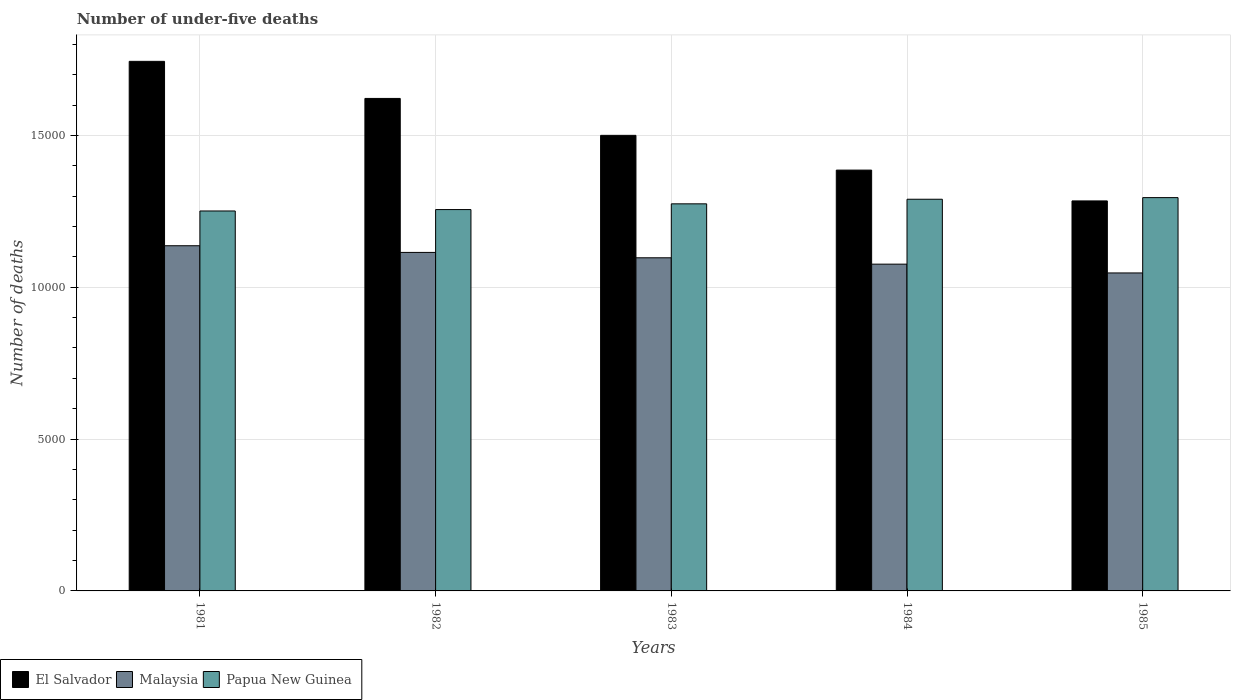How many different coloured bars are there?
Your answer should be very brief. 3. How many groups of bars are there?
Your response must be concise. 5. How many bars are there on the 1st tick from the right?
Your response must be concise. 3. What is the label of the 1st group of bars from the left?
Your response must be concise. 1981. In how many cases, is the number of bars for a given year not equal to the number of legend labels?
Your answer should be very brief. 0. What is the number of under-five deaths in El Salvador in 1983?
Give a very brief answer. 1.50e+04. Across all years, what is the maximum number of under-five deaths in Malaysia?
Make the answer very short. 1.14e+04. Across all years, what is the minimum number of under-five deaths in Papua New Guinea?
Your answer should be very brief. 1.25e+04. In which year was the number of under-five deaths in Papua New Guinea maximum?
Provide a short and direct response. 1985. What is the total number of under-five deaths in El Salvador in the graph?
Offer a terse response. 7.54e+04. What is the difference between the number of under-five deaths in Malaysia in 1983 and that in 1984?
Your answer should be very brief. 209. What is the difference between the number of under-five deaths in El Salvador in 1983 and the number of under-five deaths in Malaysia in 1985?
Your response must be concise. 4531. What is the average number of under-five deaths in Papua New Guinea per year?
Offer a very short reply. 1.27e+04. In the year 1983, what is the difference between the number of under-five deaths in Papua New Guinea and number of under-five deaths in Malaysia?
Make the answer very short. 1777. In how many years, is the number of under-five deaths in Papua New Guinea greater than 5000?
Keep it short and to the point. 5. What is the ratio of the number of under-five deaths in Papua New Guinea in 1982 to that in 1985?
Ensure brevity in your answer.  0.97. Is the difference between the number of under-five deaths in Papua New Guinea in 1982 and 1984 greater than the difference between the number of under-five deaths in Malaysia in 1982 and 1984?
Your answer should be compact. No. What is the difference between the highest and the second highest number of under-five deaths in Papua New Guinea?
Provide a succinct answer. 54. What is the difference between the highest and the lowest number of under-five deaths in El Salvador?
Offer a very short reply. 4596. Is the sum of the number of under-five deaths in Malaysia in 1981 and 1984 greater than the maximum number of under-five deaths in El Salvador across all years?
Offer a very short reply. Yes. What does the 1st bar from the left in 1984 represents?
Your answer should be very brief. El Salvador. What does the 1st bar from the right in 1981 represents?
Your answer should be very brief. Papua New Guinea. Is it the case that in every year, the sum of the number of under-five deaths in Malaysia and number of under-five deaths in Papua New Guinea is greater than the number of under-five deaths in El Salvador?
Ensure brevity in your answer.  Yes. Are all the bars in the graph horizontal?
Keep it short and to the point. No. Does the graph contain grids?
Ensure brevity in your answer.  Yes. What is the title of the graph?
Ensure brevity in your answer.  Number of under-five deaths. What is the label or title of the Y-axis?
Your answer should be very brief. Number of deaths. What is the Number of deaths in El Salvador in 1981?
Provide a short and direct response. 1.74e+04. What is the Number of deaths of Malaysia in 1981?
Make the answer very short. 1.14e+04. What is the Number of deaths of Papua New Guinea in 1981?
Keep it short and to the point. 1.25e+04. What is the Number of deaths of El Salvador in 1982?
Offer a very short reply. 1.62e+04. What is the Number of deaths in Malaysia in 1982?
Provide a succinct answer. 1.11e+04. What is the Number of deaths of Papua New Guinea in 1982?
Provide a short and direct response. 1.26e+04. What is the Number of deaths in El Salvador in 1983?
Give a very brief answer. 1.50e+04. What is the Number of deaths in Malaysia in 1983?
Offer a very short reply. 1.10e+04. What is the Number of deaths in Papua New Guinea in 1983?
Make the answer very short. 1.27e+04. What is the Number of deaths of El Salvador in 1984?
Offer a terse response. 1.39e+04. What is the Number of deaths of Malaysia in 1984?
Offer a very short reply. 1.08e+04. What is the Number of deaths in Papua New Guinea in 1984?
Make the answer very short. 1.29e+04. What is the Number of deaths in El Salvador in 1985?
Give a very brief answer. 1.28e+04. What is the Number of deaths in Malaysia in 1985?
Ensure brevity in your answer.  1.05e+04. What is the Number of deaths in Papua New Guinea in 1985?
Provide a short and direct response. 1.30e+04. Across all years, what is the maximum Number of deaths in El Salvador?
Give a very brief answer. 1.74e+04. Across all years, what is the maximum Number of deaths of Malaysia?
Your response must be concise. 1.14e+04. Across all years, what is the maximum Number of deaths in Papua New Guinea?
Your response must be concise. 1.30e+04. Across all years, what is the minimum Number of deaths of El Salvador?
Offer a terse response. 1.28e+04. Across all years, what is the minimum Number of deaths of Malaysia?
Give a very brief answer. 1.05e+04. Across all years, what is the minimum Number of deaths of Papua New Guinea?
Make the answer very short. 1.25e+04. What is the total Number of deaths of El Salvador in the graph?
Provide a short and direct response. 7.54e+04. What is the total Number of deaths of Malaysia in the graph?
Offer a terse response. 5.47e+04. What is the total Number of deaths in Papua New Guinea in the graph?
Ensure brevity in your answer.  6.37e+04. What is the difference between the Number of deaths in El Salvador in 1981 and that in 1982?
Give a very brief answer. 1221. What is the difference between the Number of deaths in Malaysia in 1981 and that in 1982?
Keep it short and to the point. 220. What is the difference between the Number of deaths of Papua New Guinea in 1981 and that in 1982?
Provide a succinct answer. -46. What is the difference between the Number of deaths in El Salvador in 1981 and that in 1983?
Your answer should be very brief. 2437. What is the difference between the Number of deaths of Malaysia in 1981 and that in 1983?
Offer a terse response. 397. What is the difference between the Number of deaths in Papua New Guinea in 1981 and that in 1983?
Give a very brief answer. -235. What is the difference between the Number of deaths of El Salvador in 1981 and that in 1984?
Make the answer very short. 3581. What is the difference between the Number of deaths in Malaysia in 1981 and that in 1984?
Ensure brevity in your answer.  606. What is the difference between the Number of deaths in Papua New Guinea in 1981 and that in 1984?
Offer a terse response. -386. What is the difference between the Number of deaths of El Salvador in 1981 and that in 1985?
Give a very brief answer. 4596. What is the difference between the Number of deaths of Malaysia in 1981 and that in 1985?
Your answer should be compact. 896. What is the difference between the Number of deaths of Papua New Guinea in 1981 and that in 1985?
Offer a terse response. -440. What is the difference between the Number of deaths of El Salvador in 1982 and that in 1983?
Make the answer very short. 1216. What is the difference between the Number of deaths of Malaysia in 1982 and that in 1983?
Offer a terse response. 177. What is the difference between the Number of deaths of Papua New Guinea in 1982 and that in 1983?
Keep it short and to the point. -189. What is the difference between the Number of deaths of El Salvador in 1982 and that in 1984?
Offer a terse response. 2360. What is the difference between the Number of deaths in Malaysia in 1982 and that in 1984?
Ensure brevity in your answer.  386. What is the difference between the Number of deaths of Papua New Guinea in 1982 and that in 1984?
Offer a very short reply. -340. What is the difference between the Number of deaths in El Salvador in 1982 and that in 1985?
Your answer should be very brief. 3375. What is the difference between the Number of deaths of Malaysia in 1982 and that in 1985?
Provide a succinct answer. 676. What is the difference between the Number of deaths in Papua New Guinea in 1982 and that in 1985?
Give a very brief answer. -394. What is the difference between the Number of deaths of El Salvador in 1983 and that in 1984?
Provide a succinct answer. 1144. What is the difference between the Number of deaths of Malaysia in 1983 and that in 1984?
Keep it short and to the point. 209. What is the difference between the Number of deaths in Papua New Guinea in 1983 and that in 1984?
Offer a terse response. -151. What is the difference between the Number of deaths of El Salvador in 1983 and that in 1985?
Offer a terse response. 2159. What is the difference between the Number of deaths in Malaysia in 1983 and that in 1985?
Provide a short and direct response. 499. What is the difference between the Number of deaths of Papua New Guinea in 1983 and that in 1985?
Your response must be concise. -205. What is the difference between the Number of deaths of El Salvador in 1984 and that in 1985?
Provide a succinct answer. 1015. What is the difference between the Number of deaths of Malaysia in 1984 and that in 1985?
Your response must be concise. 290. What is the difference between the Number of deaths in Papua New Guinea in 1984 and that in 1985?
Ensure brevity in your answer.  -54. What is the difference between the Number of deaths of El Salvador in 1981 and the Number of deaths of Malaysia in 1982?
Offer a terse response. 6292. What is the difference between the Number of deaths in El Salvador in 1981 and the Number of deaths in Papua New Guinea in 1982?
Give a very brief answer. 4881. What is the difference between the Number of deaths of Malaysia in 1981 and the Number of deaths of Papua New Guinea in 1982?
Make the answer very short. -1191. What is the difference between the Number of deaths in El Salvador in 1981 and the Number of deaths in Malaysia in 1983?
Make the answer very short. 6469. What is the difference between the Number of deaths in El Salvador in 1981 and the Number of deaths in Papua New Guinea in 1983?
Offer a very short reply. 4692. What is the difference between the Number of deaths in Malaysia in 1981 and the Number of deaths in Papua New Guinea in 1983?
Your answer should be very brief. -1380. What is the difference between the Number of deaths in El Salvador in 1981 and the Number of deaths in Malaysia in 1984?
Give a very brief answer. 6678. What is the difference between the Number of deaths in El Salvador in 1981 and the Number of deaths in Papua New Guinea in 1984?
Ensure brevity in your answer.  4541. What is the difference between the Number of deaths of Malaysia in 1981 and the Number of deaths of Papua New Guinea in 1984?
Your answer should be compact. -1531. What is the difference between the Number of deaths in El Salvador in 1981 and the Number of deaths in Malaysia in 1985?
Your answer should be compact. 6968. What is the difference between the Number of deaths in El Salvador in 1981 and the Number of deaths in Papua New Guinea in 1985?
Your response must be concise. 4487. What is the difference between the Number of deaths of Malaysia in 1981 and the Number of deaths of Papua New Guinea in 1985?
Your answer should be compact. -1585. What is the difference between the Number of deaths of El Salvador in 1982 and the Number of deaths of Malaysia in 1983?
Give a very brief answer. 5248. What is the difference between the Number of deaths in El Salvador in 1982 and the Number of deaths in Papua New Guinea in 1983?
Offer a very short reply. 3471. What is the difference between the Number of deaths in Malaysia in 1982 and the Number of deaths in Papua New Guinea in 1983?
Make the answer very short. -1600. What is the difference between the Number of deaths in El Salvador in 1982 and the Number of deaths in Malaysia in 1984?
Provide a succinct answer. 5457. What is the difference between the Number of deaths of El Salvador in 1982 and the Number of deaths of Papua New Guinea in 1984?
Ensure brevity in your answer.  3320. What is the difference between the Number of deaths in Malaysia in 1982 and the Number of deaths in Papua New Guinea in 1984?
Your response must be concise. -1751. What is the difference between the Number of deaths in El Salvador in 1982 and the Number of deaths in Malaysia in 1985?
Make the answer very short. 5747. What is the difference between the Number of deaths of El Salvador in 1982 and the Number of deaths of Papua New Guinea in 1985?
Offer a very short reply. 3266. What is the difference between the Number of deaths of Malaysia in 1982 and the Number of deaths of Papua New Guinea in 1985?
Provide a succinct answer. -1805. What is the difference between the Number of deaths of El Salvador in 1983 and the Number of deaths of Malaysia in 1984?
Make the answer very short. 4241. What is the difference between the Number of deaths in El Salvador in 1983 and the Number of deaths in Papua New Guinea in 1984?
Keep it short and to the point. 2104. What is the difference between the Number of deaths in Malaysia in 1983 and the Number of deaths in Papua New Guinea in 1984?
Offer a very short reply. -1928. What is the difference between the Number of deaths of El Salvador in 1983 and the Number of deaths of Malaysia in 1985?
Your answer should be very brief. 4531. What is the difference between the Number of deaths of El Salvador in 1983 and the Number of deaths of Papua New Guinea in 1985?
Make the answer very short. 2050. What is the difference between the Number of deaths of Malaysia in 1983 and the Number of deaths of Papua New Guinea in 1985?
Ensure brevity in your answer.  -1982. What is the difference between the Number of deaths in El Salvador in 1984 and the Number of deaths in Malaysia in 1985?
Your answer should be compact. 3387. What is the difference between the Number of deaths in El Salvador in 1984 and the Number of deaths in Papua New Guinea in 1985?
Your answer should be very brief. 906. What is the difference between the Number of deaths in Malaysia in 1984 and the Number of deaths in Papua New Guinea in 1985?
Provide a short and direct response. -2191. What is the average Number of deaths in El Salvador per year?
Make the answer very short. 1.51e+04. What is the average Number of deaths of Malaysia per year?
Offer a very short reply. 1.09e+04. What is the average Number of deaths in Papua New Guinea per year?
Offer a very short reply. 1.27e+04. In the year 1981, what is the difference between the Number of deaths in El Salvador and Number of deaths in Malaysia?
Your answer should be compact. 6072. In the year 1981, what is the difference between the Number of deaths in El Salvador and Number of deaths in Papua New Guinea?
Your answer should be compact. 4927. In the year 1981, what is the difference between the Number of deaths in Malaysia and Number of deaths in Papua New Guinea?
Ensure brevity in your answer.  -1145. In the year 1982, what is the difference between the Number of deaths of El Salvador and Number of deaths of Malaysia?
Make the answer very short. 5071. In the year 1982, what is the difference between the Number of deaths in El Salvador and Number of deaths in Papua New Guinea?
Keep it short and to the point. 3660. In the year 1982, what is the difference between the Number of deaths of Malaysia and Number of deaths of Papua New Guinea?
Your answer should be compact. -1411. In the year 1983, what is the difference between the Number of deaths in El Salvador and Number of deaths in Malaysia?
Provide a short and direct response. 4032. In the year 1983, what is the difference between the Number of deaths in El Salvador and Number of deaths in Papua New Guinea?
Make the answer very short. 2255. In the year 1983, what is the difference between the Number of deaths of Malaysia and Number of deaths of Papua New Guinea?
Give a very brief answer. -1777. In the year 1984, what is the difference between the Number of deaths in El Salvador and Number of deaths in Malaysia?
Make the answer very short. 3097. In the year 1984, what is the difference between the Number of deaths of El Salvador and Number of deaths of Papua New Guinea?
Provide a succinct answer. 960. In the year 1984, what is the difference between the Number of deaths of Malaysia and Number of deaths of Papua New Guinea?
Keep it short and to the point. -2137. In the year 1985, what is the difference between the Number of deaths in El Salvador and Number of deaths in Malaysia?
Offer a very short reply. 2372. In the year 1985, what is the difference between the Number of deaths in El Salvador and Number of deaths in Papua New Guinea?
Give a very brief answer. -109. In the year 1985, what is the difference between the Number of deaths of Malaysia and Number of deaths of Papua New Guinea?
Ensure brevity in your answer.  -2481. What is the ratio of the Number of deaths of El Salvador in 1981 to that in 1982?
Keep it short and to the point. 1.08. What is the ratio of the Number of deaths of Malaysia in 1981 to that in 1982?
Keep it short and to the point. 1.02. What is the ratio of the Number of deaths in El Salvador in 1981 to that in 1983?
Give a very brief answer. 1.16. What is the ratio of the Number of deaths of Malaysia in 1981 to that in 1983?
Give a very brief answer. 1.04. What is the ratio of the Number of deaths of Papua New Guinea in 1981 to that in 1983?
Offer a terse response. 0.98. What is the ratio of the Number of deaths in El Salvador in 1981 to that in 1984?
Offer a terse response. 1.26. What is the ratio of the Number of deaths in Malaysia in 1981 to that in 1984?
Your answer should be very brief. 1.06. What is the ratio of the Number of deaths in Papua New Guinea in 1981 to that in 1984?
Your answer should be very brief. 0.97. What is the ratio of the Number of deaths in El Salvador in 1981 to that in 1985?
Your response must be concise. 1.36. What is the ratio of the Number of deaths in Malaysia in 1981 to that in 1985?
Your answer should be very brief. 1.09. What is the ratio of the Number of deaths in El Salvador in 1982 to that in 1983?
Offer a very short reply. 1.08. What is the ratio of the Number of deaths in Malaysia in 1982 to that in 1983?
Provide a succinct answer. 1.02. What is the ratio of the Number of deaths of Papua New Guinea in 1982 to that in 1983?
Your answer should be compact. 0.99. What is the ratio of the Number of deaths of El Salvador in 1982 to that in 1984?
Keep it short and to the point. 1.17. What is the ratio of the Number of deaths of Malaysia in 1982 to that in 1984?
Make the answer very short. 1.04. What is the ratio of the Number of deaths of Papua New Guinea in 1982 to that in 1984?
Provide a short and direct response. 0.97. What is the ratio of the Number of deaths in El Salvador in 1982 to that in 1985?
Offer a terse response. 1.26. What is the ratio of the Number of deaths in Malaysia in 1982 to that in 1985?
Offer a very short reply. 1.06. What is the ratio of the Number of deaths of Papua New Guinea in 1982 to that in 1985?
Provide a succinct answer. 0.97. What is the ratio of the Number of deaths of El Salvador in 1983 to that in 1984?
Ensure brevity in your answer.  1.08. What is the ratio of the Number of deaths in Malaysia in 1983 to that in 1984?
Ensure brevity in your answer.  1.02. What is the ratio of the Number of deaths of Papua New Guinea in 1983 to that in 1984?
Provide a succinct answer. 0.99. What is the ratio of the Number of deaths of El Salvador in 1983 to that in 1985?
Offer a very short reply. 1.17. What is the ratio of the Number of deaths in Malaysia in 1983 to that in 1985?
Make the answer very short. 1.05. What is the ratio of the Number of deaths of Papua New Guinea in 1983 to that in 1985?
Give a very brief answer. 0.98. What is the ratio of the Number of deaths of El Salvador in 1984 to that in 1985?
Offer a terse response. 1.08. What is the ratio of the Number of deaths of Malaysia in 1984 to that in 1985?
Ensure brevity in your answer.  1.03. What is the difference between the highest and the second highest Number of deaths of El Salvador?
Offer a very short reply. 1221. What is the difference between the highest and the second highest Number of deaths of Malaysia?
Ensure brevity in your answer.  220. What is the difference between the highest and the lowest Number of deaths in El Salvador?
Provide a short and direct response. 4596. What is the difference between the highest and the lowest Number of deaths in Malaysia?
Ensure brevity in your answer.  896. What is the difference between the highest and the lowest Number of deaths of Papua New Guinea?
Offer a terse response. 440. 